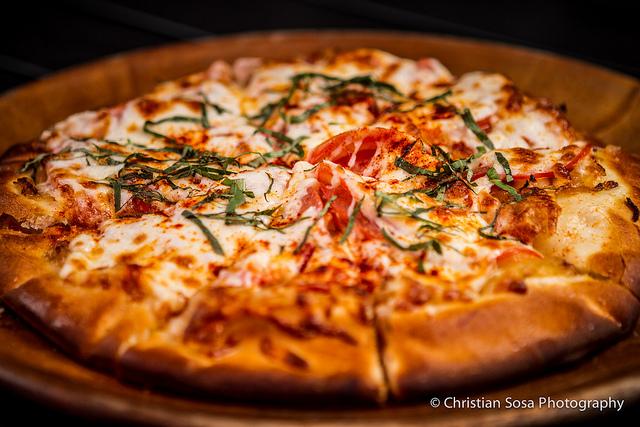Is this food crumbling?
Keep it brief. No. What type of cheese is that?
Be succinct. Mozzarella. This dish is made primarily of what food?
Concise answer only. Pizza. What are the greens on the pizza?
Give a very brief answer. Basil. Are there onions on this pizza?
Short answer required. No. What type of food is shown to the right?
Give a very brief answer. Pizza. Is it cooked yet?
Keep it brief. Yes. What is mainly featured?
Quick response, please. Pizza. Is the pizza thin crust or deep dish?
Short answer required. Thin. Did someone steal a slice of pizza?
Keep it brief. No. What is the Green item on the pizza?
Answer briefly. Basil. What meal is this?
Be succinct. Dinner. What kind of food is that?
Keep it brief. Pizza. What color is the plate?
Be succinct. Brown. Who took the photograph?
Quick response, please. Christian sosa. What kind of vegetables are on the pizza?
Short answer required. Tomato. What color is the plate the food is on?
Answer briefly. Brown. Is that mushrooms on the pizza?
Keep it brief. No. Is the pizza thin crust or thick crust?
Quick response, please. Thick. 